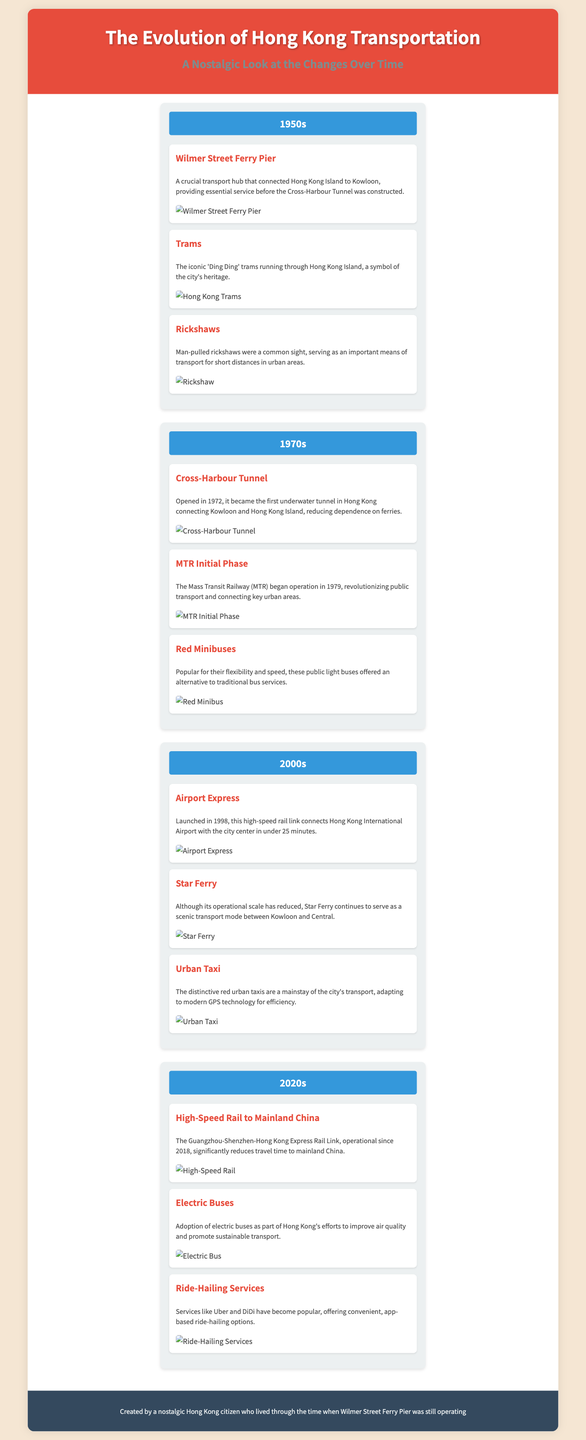what was a crucial transport hub in the 1950s? The document highlights Wilmer Street Ferry Pier as a crucial transport hub that connected Hong Kong Island to Kowloon in the 1950s.
Answer: Wilmer Street Ferry Pier when did the Cross-Harbour Tunnel open? The document states that the Cross-Harbour Tunnel opened in 1972.
Answer: 1972 what transport mode began operation in 1979? According to the document, the Mass Transit Railway (MTR) began operation in 1979, revolutionizing public transport.
Answer: Mass Transit Railway (MTR) which transportation service connects the airport with the city center? The document notes that the Airport Express connects Hong Kong International Airport with the city center.
Answer: Airport Express what type of buses are being adopted to improve air quality? The document mentions that electric buses are being adopted as part of efforts to improve air quality.
Answer: Electric Buses what was a common sight for short distances in the 1950s? The document states that man-pulled rickshaws were a common sight for short distances in the urban areas during the 1950s.
Answer: Rickshaws which ferry service is still operational but on a reduced scale? The document indicates that Star Ferry continues to serve as a scenic transport mode between Kowloon and Central, although its operational scale has reduced.
Answer: Star Ferry what represents modern ride-hailing options? According to the document, services like Uber and DiDi represent modern ride-hailing options that have become popular.
Answer: Uber and DiDi which tunnel reduced dependence on ferries? The document mentions that the Cross-Harbour Tunnel, opened in 1972, reduced dependence on ferries.
Answer: Cross-Harbour Tunnel 